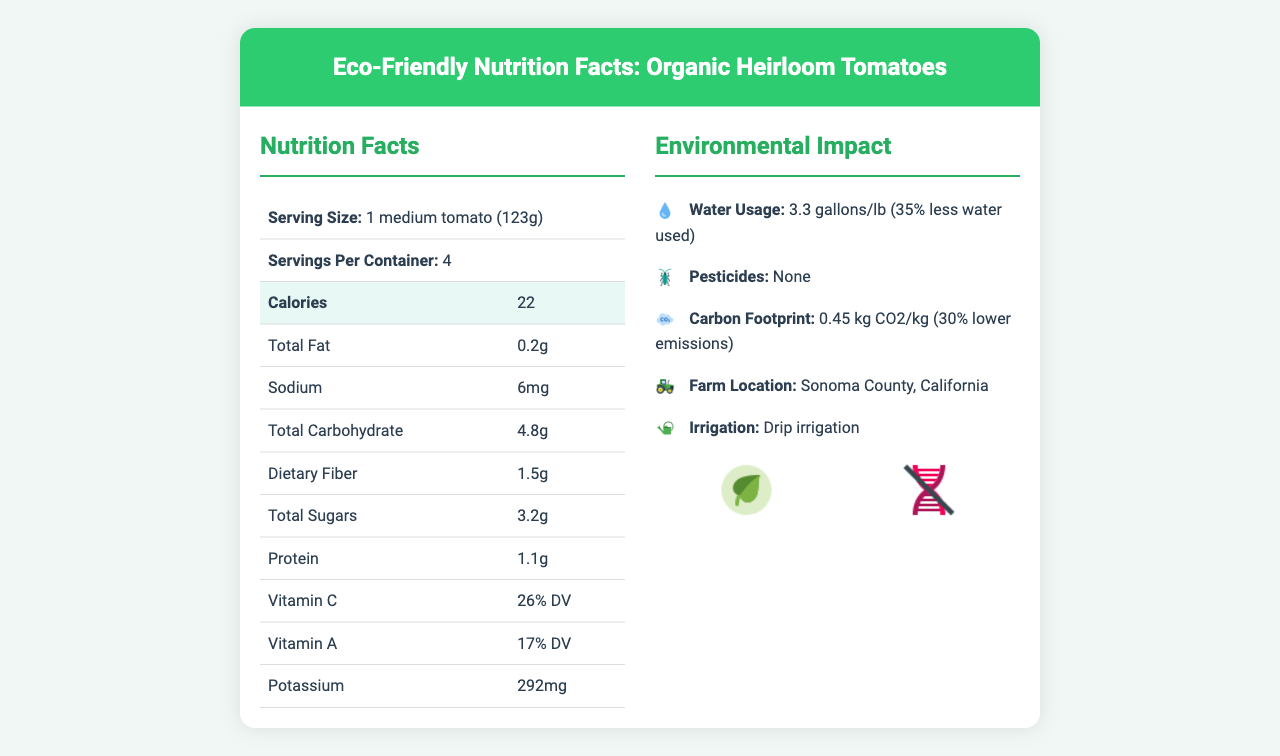What is the serving size for Organic Heirloom Tomatoes? The serving size is clearly listed under the Nutrition Facts section as 1 medium tomato weighing 123 grams.
Answer: 1 medium tomato (123g) How many calories are there per serving? According to the Nutrition Facts table, there are 22 calories per serving.
Answer: 22 calories What percentage of the daily value of Vitamin C do these tomatoes provide? The Nutrition Facts table lists Vitamin C content as 26% of the daily value.
Answer: 26% DV How much potassium is in each serving of Organic Heirloom Tomatoes? The amount of potassium is specified in the Nutrition Facts table as 292mg per serving.
Answer: 292mg Which type of pesticides are used for Organic Heirloom Tomatoes? The document specifies that synthetic pesticides are not used, and organic pest control methods like Neem oil and beneficial insects are employed.
Answer: None How does the water usage of these tomatoes compare to conventional tomatoes? The environmental impact section mentions that the water usage for these tomatoes is 35% less compared to conventional tomatoes.
Answer: 35% less water used What are the certifications held by this product? A. USDA Organic B. Non-GMO Project Verified C. Fair Trade D. Certified Humane The document includes icons and text for USDA Organic and Non-GMO Project Verified, indicating these certifications.
Answer: A and B How long is the shelf life of Organic Heirloom Tomatoes at room temperature? A. 3-5 days B. 5-7 days C. 7-10 days D. 10-12 days The document states that the shelf life of the tomatoes is 5-7 days at room temperature.
Answer: B What percentage of solar energy is used by the farm? In the section on farm energy sources, it states that 50% of the farm's energy comes from solar power.
Answer: 50% Does the farm use any synthetic pesticides for these tomatoes? The pesticide information specifies that no synthetic pesticides are used.
Answer: No Summarize the main idea of the document. The document is divided into sections that highlight the nutritional content, water usage, pesticide avoidance, soil health, carbon footprint, farm location, irrigation type, certifications, environmental benefits, and energy sources.
Answer: The document provides Nutrition Facts and environmental impact information for Organic Heirloom Tomatoes, emphasizing their health benefits, sustainable farming practices, water usage, carbon footprint, certifications, and energy sources. Where is the farm located that grows these tomatoes? The farm location is specified as Sonoma County, California, in the environmental impact section.
Answer: Sonoma County, California Can the amount of dietary fiber in one serving be determined? The amount of dietary fiber per serving is listed as 1.5g in the Nutrition Facts section.
Answer: Yes What organic pest control methods are used? The pesticide information section mentions Neem oil and beneficial insects as organic pest control methods.
Answer: Neem oil, beneficial insects What is the total carbohydrate content per serving? The Nutrition Facts section lists total carbohydrates as 4.8g per serving.
Answer: 4.8g Is the irrigation type for these tomatoes specified as drip irrigation? The document states that the irrigation type used is drip irrigation.
Answer: Yes How do the antioxidant levels in these tomatoes compare to conventional tomatoes? The nutritional comparison section mentions that these tomatoes have 30% more antioxidants compared to conventional tomatoes.
Answer: +30% What is the carbon footprint of these tomatoes per kilogram of produce? The carbon footprint is listed as 0.45 kg CO2 per kilogram of produce.
Answer: 0.45 kg CO2/kg What type of packaging is used for these tomatoes? The document mentions that the packaging is a recyclable cardboard container.
Answer: Recyclable cardboard container What is the farm’s energy source besides solar? The document mentions that the farm's energy sources are 50% solar and 50% grid electricity, which is 100% renewable.
Answer: Grid electricity (100% renewable) 